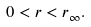<formula> <loc_0><loc_0><loc_500><loc_500>0 < r < r _ { \infty } .</formula> 